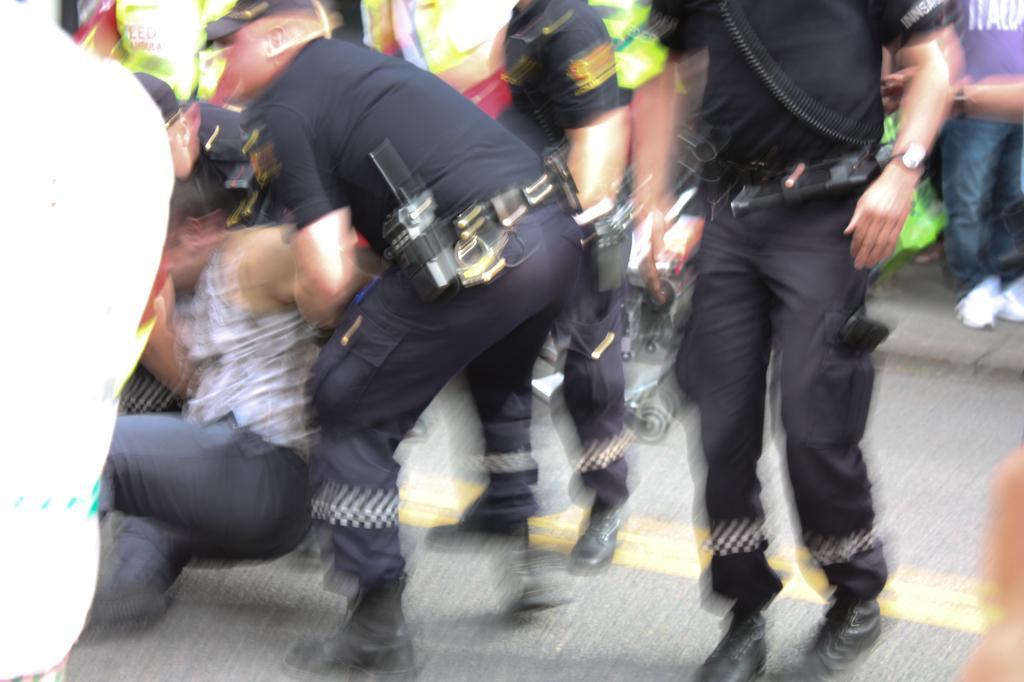Can you describe this image briefly? In this image I can see there are four persons standing on the floor and on the left side I can see two persons, they both are holding another person and on the right side I can see a person´s and I can see a person standing on the floor and the person wearing a blue color t-shirt. 